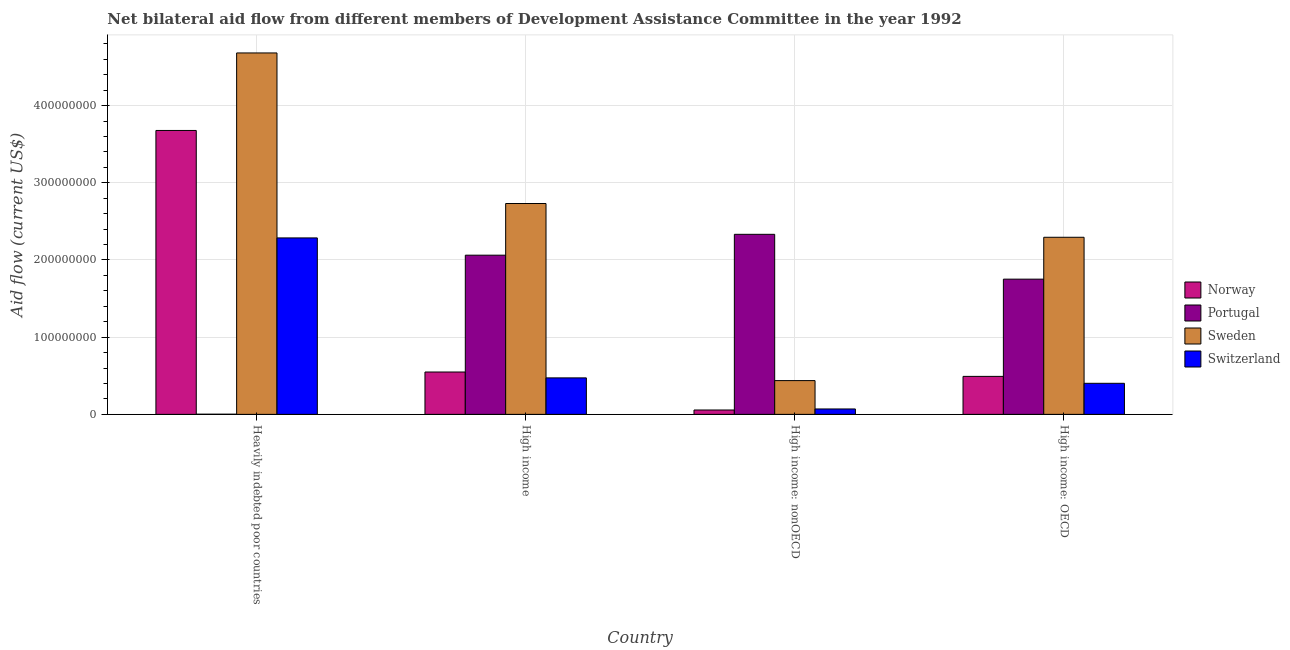Are the number of bars per tick equal to the number of legend labels?
Provide a short and direct response. Yes. How many bars are there on the 1st tick from the left?
Ensure brevity in your answer.  4. What is the label of the 3rd group of bars from the left?
Your response must be concise. High income: nonOECD. In how many cases, is the number of bars for a given country not equal to the number of legend labels?
Provide a short and direct response. 0. What is the amount of aid given by switzerland in High income?
Your response must be concise. 4.73e+07. Across all countries, what is the maximum amount of aid given by switzerland?
Offer a very short reply. 2.29e+08. Across all countries, what is the minimum amount of aid given by switzerland?
Offer a very short reply. 7.02e+06. In which country was the amount of aid given by portugal maximum?
Make the answer very short. High income: nonOECD. In which country was the amount of aid given by portugal minimum?
Provide a succinct answer. Heavily indebted poor countries. What is the total amount of aid given by norway in the graph?
Offer a very short reply. 4.78e+08. What is the difference between the amount of aid given by sweden in Heavily indebted poor countries and that in High income: nonOECD?
Make the answer very short. 4.24e+08. What is the difference between the amount of aid given by portugal in High income: OECD and the amount of aid given by sweden in High income?
Ensure brevity in your answer.  -9.80e+07. What is the average amount of aid given by sweden per country?
Provide a short and direct response. 2.54e+08. What is the difference between the amount of aid given by switzerland and amount of aid given by norway in Heavily indebted poor countries?
Make the answer very short. -1.39e+08. In how many countries, is the amount of aid given by switzerland greater than 200000000 US$?
Offer a very short reply. 1. What is the ratio of the amount of aid given by sweden in Heavily indebted poor countries to that in High income: nonOECD?
Give a very brief answer. 10.7. Is the amount of aid given by sweden in High income less than that in High income: nonOECD?
Your response must be concise. No. What is the difference between the highest and the second highest amount of aid given by switzerland?
Offer a terse response. 1.81e+08. What is the difference between the highest and the lowest amount of aid given by sweden?
Your answer should be compact. 4.24e+08. In how many countries, is the amount of aid given by sweden greater than the average amount of aid given by sweden taken over all countries?
Your answer should be compact. 2. Is the sum of the amount of aid given by norway in High income and High income: nonOECD greater than the maximum amount of aid given by sweden across all countries?
Your answer should be very brief. No. Is it the case that in every country, the sum of the amount of aid given by sweden and amount of aid given by portugal is greater than the sum of amount of aid given by switzerland and amount of aid given by norway?
Provide a short and direct response. Yes. What does the 4th bar from the left in High income represents?
Provide a short and direct response. Switzerland. What does the 1st bar from the right in High income represents?
Provide a succinct answer. Switzerland. How many bars are there?
Offer a very short reply. 16. Are all the bars in the graph horizontal?
Your response must be concise. No. What is the difference between two consecutive major ticks on the Y-axis?
Provide a succinct answer. 1.00e+08. Does the graph contain any zero values?
Keep it short and to the point. No. Does the graph contain grids?
Provide a succinct answer. Yes. How many legend labels are there?
Provide a short and direct response. 4. What is the title of the graph?
Offer a terse response. Net bilateral aid flow from different members of Development Assistance Committee in the year 1992. What is the Aid flow (current US$) in Norway in Heavily indebted poor countries?
Give a very brief answer. 3.68e+08. What is the Aid flow (current US$) in Sweden in Heavily indebted poor countries?
Your answer should be very brief. 4.68e+08. What is the Aid flow (current US$) of Switzerland in Heavily indebted poor countries?
Offer a terse response. 2.29e+08. What is the Aid flow (current US$) in Norway in High income?
Your answer should be very brief. 5.49e+07. What is the Aid flow (current US$) of Portugal in High income?
Keep it short and to the point. 2.06e+08. What is the Aid flow (current US$) of Sweden in High income?
Offer a very short reply. 2.73e+08. What is the Aid flow (current US$) of Switzerland in High income?
Provide a succinct answer. 4.73e+07. What is the Aid flow (current US$) in Norway in High income: nonOECD?
Keep it short and to the point. 5.67e+06. What is the Aid flow (current US$) of Portugal in High income: nonOECD?
Make the answer very short. 2.33e+08. What is the Aid flow (current US$) of Sweden in High income: nonOECD?
Provide a short and direct response. 4.38e+07. What is the Aid flow (current US$) of Switzerland in High income: nonOECD?
Your response must be concise. 7.02e+06. What is the Aid flow (current US$) of Norway in High income: OECD?
Your answer should be compact. 4.92e+07. What is the Aid flow (current US$) in Portugal in High income: OECD?
Give a very brief answer. 1.75e+08. What is the Aid flow (current US$) in Sweden in High income: OECD?
Offer a terse response. 2.29e+08. What is the Aid flow (current US$) in Switzerland in High income: OECD?
Make the answer very short. 4.02e+07. Across all countries, what is the maximum Aid flow (current US$) in Norway?
Give a very brief answer. 3.68e+08. Across all countries, what is the maximum Aid flow (current US$) of Portugal?
Keep it short and to the point. 2.33e+08. Across all countries, what is the maximum Aid flow (current US$) of Sweden?
Keep it short and to the point. 4.68e+08. Across all countries, what is the maximum Aid flow (current US$) in Switzerland?
Your answer should be compact. 2.29e+08. Across all countries, what is the minimum Aid flow (current US$) of Norway?
Your answer should be very brief. 5.67e+06. Across all countries, what is the minimum Aid flow (current US$) of Sweden?
Your response must be concise. 4.38e+07. Across all countries, what is the minimum Aid flow (current US$) in Switzerland?
Give a very brief answer. 7.02e+06. What is the total Aid flow (current US$) of Norway in the graph?
Ensure brevity in your answer.  4.78e+08. What is the total Aid flow (current US$) of Portugal in the graph?
Offer a terse response. 6.15e+08. What is the total Aid flow (current US$) in Sweden in the graph?
Your answer should be very brief. 1.01e+09. What is the total Aid flow (current US$) of Switzerland in the graph?
Offer a terse response. 3.23e+08. What is the difference between the Aid flow (current US$) of Norway in Heavily indebted poor countries and that in High income?
Ensure brevity in your answer.  3.13e+08. What is the difference between the Aid flow (current US$) in Portugal in Heavily indebted poor countries and that in High income?
Offer a terse response. -2.06e+08. What is the difference between the Aid flow (current US$) of Sweden in Heavily indebted poor countries and that in High income?
Provide a succinct answer. 1.95e+08. What is the difference between the Aid flow (current US$) of Switzerland in Heavily indebted poor countries and that in High income?
Ensure brevity in your answer.  1.81e+08. What is the difference between the Aid flow (current US$) of Norway in Heavily indebted poor countries and that in High income: nonOECD?
Offer a very short reply. 3.62e+08. What is the difference between the Aid flow (current US$) of Portugal in Heavily indebted poor countries and that in High income: nonOECD?
Your response must be concise. -2.33e+08. What is the difference between the Aid flow (current US$) in Sweden in Heavily indebted poor countries and that in High income: nonOECD?
Make the answer very short. 4.24e+08. What is the difference between the Aid flow (current US$) of Switzerland in Heavily indebted poor countries and that in High income: nonOECD?
Give a very brief answer. 2.22e+08. What is the difference between the Aid flow (current US$) of Norway in Heavily indebted poor countries and that in High income: OECD?
Provide a succinct answer. 3.19e+08. What is the difference between the Aid flow (current US$) in Portugal in Heavily indebted poor countries and that in High income: OECD?
Your answer should be compact. -1.75e+08. What is the difference between the Aid flow (current US$) of Sweden in Heavily indebted poor countries and that in High income: OECD?
Offer a terse response. 2.39e+08. What is the difference between the Aid flow (current US$) of Switzerland in Heavily indebted poor countries and that in High income: OECD?
Keep it short and to the point. 1.88e+08. What is the difference between the Aid flow (current US$) in Norway in High income and that in High income: nonOECD?
Make the answer very short. 4.92e+07. What is the difference between the Aid flow (current US$) of Portugal in High income and that in High income: nonOECD?
Keep it short and to the point. -2.70e+07. What is the difference between the Aid flow (current US$) of Sweden in High income and that in High income: nonOECD?
Provide a succinct answer. 2.29e+08. What is the difference between the Aid flow (current US$) of Switzerland in High income and that in High income: nonOECD?
Make the answer very short. 4.02e+07. What is the difference between the Aid flow (current US$) of Norway in High income and that in High income: OECD?
Provide a succinct answer. 5.67e+06. What is the difference between the Aid flow (current US$) of Portugal in High income and that in High income: OECD?
Ensure brevity in your answer.  3.11e+07. What is the difference between the Aid flow (current US$) of Sweden in High income and that in High income: OECD?
Your response must be concise. 4.38e+07. What is the difference between the Aid flow (current US$) in Switzerland in High income and that in High income: OECD?
Make the answer very short. 7.02e+06. What is the difference between the Aid flow (current US$) of Norway in High income: nonOECD and that in High income: OECD?
Make the answer very short. -4.36e+07. What is the difference between the Aid flow (current US$) in Portugal in High income: nonOECD and that in High income: OECD?
Make the answer very short. 5.81e+07. What is the difference between the Aid flow (current US$) of Sweden in High income: nonOECD and that in High income: OECD?
Ensure brevity in your answer.  -1.86e+08. What is the difference between the Aid flow (current US$) of Switzerland in High income: nonOECD and that in High income: OECD?
Provide a succinct answer. -3.32e+07. What is the difference between the Aid flow (current US$) in Norway in Heavily indebted poor countries and the Aid flow (current US$) in Portugal in High income?
Make the answer very short. 1.62e+08. What is the difference between the Aid flow (current US$) of Norway in Heavily indebted poor countries and the Aid flow (current US$) of Sweden in High income?
Offer a very short reply. 9.46e+07. What is the difference between the Aid flow (current US$) of Norway in Heavily indebted poor countries and the Aid flow (current US$) of Switzerland in High income?
Your response must be concise. 3.21e+08. What is the difference between the Aid flow (current US$) in Portugal in Heavily indebted poor countries and the Aid flow (current US$) in Sweden in High income?
Your response must be concise. -2.73e+08. What is the difference between the Aid flow (current US$) in Portugal in Heavily indebted poor countries and the Aid flow (current US$) in Switzerland in High income?
Keep it short and to the point. -4.70e+07. What is the difference between the Aid flow (current US$) of Sweden in Heavily indebted poor countries and the Aid flow (current US$) of Switzerland in High income?
Keep it short and to the point. 4.21e+08. What is the difference between the Aid flow (current US$) in Norway in Heavily indebted poor countries and the Aid flow (current US$) in Portugal in High income: nonOECD?
Give a very brief answer. 1.35e+08. What is the difference between the Aid flow (current US$) of Norway in Heavily indebted poor countries and the Aid flow (current US$) of Sweden in High income: nonOECD?
Your answer should be compact. 3.24e+08. What is the difference between the Aid flow (current US$) of Norway in Heavily indebted poor countries and the Aid flow (current US$) of Switzerland in High income: nonOECD?
Provide a short and direct response. 3.61e+08. What is the difference between the Aid flow (current US$) in Portugal in Heavily indebted poor countries and the Aid flow (current US$) in Sweden in High income: nonOECD?
Your answer should be compact. -4.35e+07. What is the difference between the Aid flow (current US$) in Portugal in Heavily indebted poor countries and the Aid flow (current US$) in Switzerland in High income: nonOECD?
Offer a terse response. -6.80e+06. What is the difference between the Aid flow (current US$) in Sweden in Heavily indebted poor countries and the Aid flow (current US$) in Switzerland in High income: nonOECD?
Keep it short and to the point. 4.61e+08. What is the difference between the Aid flow (current US$) of Norway in Heavily indebted poor countries and the Aid flow (current US$) of Portugal in High income: OECD?
Your answer should be very brief. 1.93e+08. What is the difference between the Aid flow (current US$) in Norway in Heavily indebted poor countries and the Aid flow (current US$) in Sweden in High income: OECD?
Provide a succinct answer. 1.38e+08. What is the difference between the Aid flow (current US$) in Norway in Heavily indebted poor countries and the Aid flow (current US$) in Switzerland in High income: OECD?
Keep it short and to the point. 3.28e+08. What is the difference between the Aid flow (current US$) of Portugal in Heavily indebted poor countries and the Aid flow (current US$) of Sweden in High income: OECD?
Give a very brief answer. -2.29e+08. What is the difference between the Aid flow (current US$) of Portugal in Heavily indebted poor countries and the Aid flow (current US$) of Switzerland in High income: OECD?
Your response must be concise. -4.00e+07. What is the difference between the Aid flow (current US$) in Sweden in Heavily indebted poor countries and the Aid flow (current US$) in Switzerland in High income: OECD?
Provide a short and direct response. 4.28e+08. What is the difference between the Aid flow (current US$) of Norway in High income and the Aid flow (current US$) of Portugal in High income: nonOECD?
Provide a succinct answer. -1.78e+08. What is the difference between the Aid flow (current US$) of Norway in High income and the Aid flow (current US$) of Sweden in High income: nonOECD?
Your response must be concise. 1.11e+07. What is the difference between the Aid flow (current US$) of Norway in High income and the Aid flow (current US$) of Switzerland in High income: nonOECD?
Offer a very short reply. 4.79e+07. What is the difference between the Aid flow (current US$) in Portugal in High income and the Aid flow (current US$) in Sweden in High income: nonOECD?
Your response must be concise. 1.62e+08. What is the difference between the Aid flow (current US$) of Portugal in High income and the Aid flow (current US$) of Switzerland in High income: nonOECD?
Keep it short and to the point. 1.99e+08. What is the difference between the Aid flow (current US$) in Sweden in High income and the Aid flow (current US$) in Switzerland in High income: nonOECD?
Ensure brevity in your answer.  2.66e+08. What is the difference between the Aid flow (current US$) in Norway in High income and the Aid flow (current US$) in Portugal in High income: OECD?
Provide a succinct answer. -1.20e+08. What is the difference between the Aid flow (current US$) in Norway in High income and the Aid flow (current US$) in Sweden in High income: OECD?
Keep it short and to the point. -1.75e+08. What is the difference between the Aid flow (current US$) of Norway in High income and the Aid flow (current US$) of Switzerland in High income: OECD?
Keep it short and to the point. 1.46e+07. What is the difference between the Aid flow (current US$) in Portugal in High income and the Aid flow (current US$) in Sweden in High income: OECD?
Keep it short and to the point. -2.32e+07. What is the difference between the Aid flow (current US$) of Portugal in High income and the Aid flow (current US$) of Switzerland in High income: OECD?
Offer a terse response. 1.66e+08. What is the difference between the Aid flow (current US$) in Sweden in High income and the Aid flow (current US$) in Switzerland in High income: OECD?
Give a very brief answer. 2.33e+08. What is the difference between the Aid flow (current US$) of Norway in High income: nonOECD and the Aid flow (current US$) of Portugal in High income: OECD?
Offer a terse response. -1.70e+08. What is the difference between the Aid flow (current US$) of Norway in High income: nonOECD and the Aid flow (current US$) of Sweden in High income: OECD?
Give a very brief answer. -2.24e+08. What is the difference between the Aid flow (current US$) in Norway in High income: nonOECD and the Aid flow (current US$) in Switzerland in High income: OECD?
Make the answer very short. -3.46e+07. What is the difference between the Aid flow (current US$) of Portugal in High income: nonOECD and the Aid flow (current US$) of Sweden in High income: OECD?
Keep it short and to the point. 3.82e+06. What is the difference between the Aid flow (current US$) of Portugal in High income: nonOECD and the Aid flow (current US$) of Switzerland in High income: OECD?
Make the answer very short. 1.93e+08. What is the difference between the Aid flow (current US$) in Sweden in High income: nonOECD and the Aid flow (current US$) in Switzerland in High income: OECD?
Your response must be concise. 3.50e+06. What is the average Aid flow (current US$) of Norway per country?
Offer a very short reply. 1.19e+08. What is the average Aid flow (current US$) of Portugal per country?
Your answer should be very brief. 1.54e+08. What is the average Aid flow (current US$) of Sweden per country?
Your answer should be compact. 2.54e+08. What is the average Aid flow (current US$) in Switzerland per country?
Provide a succinct answer. 8.08e+07. What is the difference between the Aid flow (current US$) of Norway and Aid flow (current US$) of Portugal in Heavily indebted poor countries?
Make the answer very short. 3.68e+08. What is the difference between the Aid flow (current US$) of Norway and Aid flow (current US$) of Sweden in Heavily indebted poor countries?
Your response must be concise. -1.00e+08. What is the difference between the Aid flow (current US$) in Norway and Aid flow (current US$) in Switzerland in Heavily indebted poor countries?
Offer a terse response. 1.39e+08. What is the difference between the Aid flow (current US$) in Portugal and Aid flow (current US$) in Sweden in Heavily indebted poor countries?
Ensure brevity in your answer.  -4.68e+08. What is the difference between the Aid flow (current US$) of Portugal and Aid flow (current US$) of Switzerland in Heavily indebted poor countries?
Offer a terse response. -2.28e+08. What is the difference between the Aid flow (current US$) of Sweden and Aid flow (current US$) of Switzerland in Heavily indebted poor countries?
Your response must be concise. 2.40e+08. What is the difference between the Aid flow (current US$) of Norway and Aid flow (current US$) of Portugal in High income?
Make the answer very short. -1.51e+08. What is the difference between the Aid flow (current US$) in Norway and Aid flow (current US$) in Sweden in High income?
Your answer should be very brief. -2.18e+08. What is the difference between the Aid flow (current US$) of Norway and Aid flow (current US$) of Switzerland in High income?
Your answer should be very brief. 7.62e+06. What is the difference between the Aid flow (current US$) in Portugal and Aid flow (current US$) in Sweden in High income?
Make the answer very short. -6.70e+07. What is the difference between the Aid flow (current US$) of Portugal and Aid flow (current US$) of Switzerland in High income?
Keep it short and to the point. 1.59e+08. What is the difference between the Aid flow (current US$) of Sweden and Aid flow (current US$) of Switzerland in High income?
Your answer should be compact. 2.26e+08. What is the difference between the Aid flow (current US$) of Norway and Aid flow (current US$) of Portugal in High income: nonOECD?
Your answer should be very brief. -2.28e+08. What is the difference between the Aid flow (current US$) in Norway and Aid flow (current US$) in Sweden in High income: nonOECD?
Offer a very short reply. -3.81e+07. What is the difference between the Aid flow (current US$) of Norway and Aid flow (current US$) of Switzerland in High income: nonOECD?
Your response must be concise. -1.35e+06. What is the difference between the Aid flow (current US$) in Portugal and Aid flow (current US$) in Sweden in High income: nonOECD?
Offer a terse response. 1.90e+08. What is the difference between the Aid flow (current US$) in Portugal and Aid flow (current US$) in Switzerland in High income: nonOECD?
Keep it short and to the point. 2.26e+08. What is the difference between the Aid flow (current US$) in Sweden and Aid flow (current US$) in Switzerland in High income: nonOECD?
Provide a succinct answer. 3.67e+07. What is the difference between the Aid flow (current US$) of Norway and Aid flow (current US$) of Portugal in High income: OECD?
Ensure brevity in your answer.  -1.26e+08. What is the difference between the Aid flow (current US$) in Norway and Aid flow (current US$) in Sweden in High income: OECD?
Offer a very short reply. -1.80e+08. What is the difference between the Aid flow (current US$) of Norway and Aid flow (current US$) of Switzerland in High income: OECD?
Offer a very short reply. 8.97e+06. What is the difference between the Aid flow (current US$) of Portugal and Aid flow (current US$) of Sweden in High income: OECD?
Ensure brevity in your answer.  -5.43e+07. What is the difference between the Aid flow (current US$) in Portugal and Aid flow (current US$) in Switzerland in High income: OECD?
Provide a succinct answer. 1.35e+08. What is the difference between the Aid flow (current US$) of Sweden and Aid flow (current US$) of Switzerland in High income: OECD?
Make the answer very short. 1.89e+08. What is the ratio of the Aid flow (current US$) of Norway in Heavily indebted poor countries to that in High income?
Provide a succinct answer. 6.7. What is the ratio of the Aid flow (current US$) in Portugal in Heavily indebted poor countries to that in High income?
Offer a terse response. 0. What is the ratio of the Aid flow (current US$) in Sweden in Heavily indebted poor countries to that in High income?
Keep it short and to the point. 1.71. What is the ratio of the Aid flow (current US$) of Switzerland in Heavily indebted poor countries to that in High income?
Keep it short and to the point. 4.84. What is the ratio of the Aid flow (current US$) of Norway in Heavily indebted poor countries to that in High income: nonOECD?
Your response must be concise. 64.87. What is the ratio of the Aid flow (current US$) in Portugal in Heavily indebted poor countries to that in High income: nonOECD?
Offer a very short reply. 0. What is the ratio of the Aid flow (current US$) in Sweden in Heavily indebted poor countries to that in High income: nonOECD?
Your response must be concise. 10.7. What is the ratio of the Aid flow (current US$) in Switzerland in Heavily indebted poor countries to that in High income: nonOECD?
Your answer should be compact. 32.56. What is the ratio of the Aid flow (current US$) in Norway in Heavily indebted poor countries to that in High income: OECD?
Offer a terse response. 7.47. What is the ratio of the Aid flow (current US$) of Portugal in Heavily indebted poor countries to that in High income: OECD?
Your answer should be compact. 0. What is the ratio of the Aid flow (current US$) in Sweden in Heavily indebted poor countries to that in High income: OECD?
Give a very brief answer. 2.04. What is the ratio of the Aid flow (current US$) in Switzerland in Heavily indebted poor countries to that in High income: OECD?
Ensure brevity in your answer.  5.68. What is the ratio of the Aid flow (current US$) in Norway in High income to that in High income: nonOECD?
Offer a very short reply. 9.68. What is the ratio of the Aid flow (current US$) in Portugal in High income to that in High income: nonOECD?
Offer a very short reply. 0.88. What is the ratio of the Aid flow (current US$) in Sweden in High income to that in High income: nonOECD?
Your answer should be compact. 6.24. What is the ratio of the Aid flow (current US$) of Switzerland in High income to that in High income: nonOECD?
Give a very brief answer. 6.73. What is the ratio of the Aid flow (current US$) of Norway in High income to that in High income: OECD?
Ensure brevity in your answer.  1.12. What is the ratio of the Aid flow (current US$) in Portugal in High income to that in High income: OECD?
Your answer should be compact. 1.18. What is the ratio of the Aid flow (current US$) of Sweden in High income to that in High income: OECD?
Make the answer very short. 1.19. What is the ratio of the Aid flow (current US$) in Switzerland in High income to that in High income: OECD?
Offer a terse response. 1.17. What is the ratio of the Aid flow (current US$) in Norway in High income: nonOECD to that in High income: OECD?
Keep it short and to the point. 0.12. What is the ratio of the Aid flow (current US$) of Portugal in High income: nonOECD to that in High income: OECD?
Offer a terse response. 1.33. What is the ratio of the Aid flow (current US$) of Sweden in High income: nonOECD to that in High income: OECD?
Offer a terse response. 0.19. What is the ratio of the Aid flow (current US$) of Switzerland in High income: nonOECD to that in High income: OECD?
Offer a terse response. 0.17. What is the difference between the highest and the second highest Aid flow (current US$) of Norway?
Make the answer very short. 3.13e+08. What is the difference between the highest and the second highest Aid flow (current US$) in Portugal?
Offer a terse response. 2.70e+07. What is the difference between the highest and the second highest Aid flow (current US$) in Sweden?
Provide a short and direct response. 1.95e+08. What is the difference between the highest and the second highest Aid flow (current US$) in Switzerland?
Your answer should be very brief. 1.81e+08. What is the difference between the highest and the lowest Aid flow (current US$) of Norway?
Offer a terse response. 3.62e+08. What is the difference between the highest and the lowest Aid flow (current US$) of Portugal?
Offer a terse response. 2.33e+08. What is the difference between the highest and the lowest Aid flow (current US$) of Sweden?
Offer a terse response. 4.24e+08. What is the difference between the highest and the lowest Aid flow (current US$) in Switzerland?
Keep it short and to the point. 2.22e+08. 